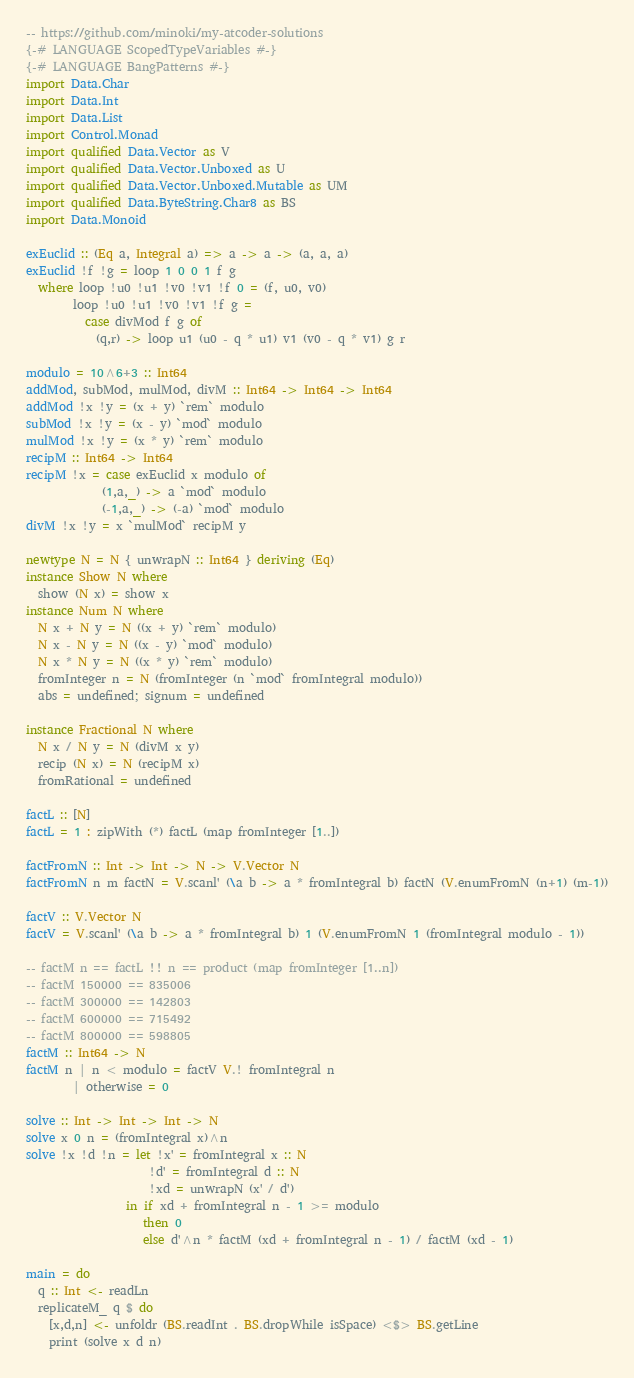<code> <loc_0><loc_0><loc_500><loc_500><_Haskell_>-- https://github.com/minoki/my-atcoder-solutions
{-# LANGUAGE ScopedTypeVariables #-}
{-# LANGUAGE BangPatterns #-}
import Data.Char
import Data.Int
import Data.List
import Control.Monad
import qualified Data.Vector as V
import qualified Data.Vector.Unboxed as U
import qualified Data.Vector.Unboxed.Mutable as UM
import qualified Data.ByteString.Char8 as BS
import Data.Monoid

exEuclid :: (Eq a, Integral a) => a -> a -> (a, a, a)
exEuclid !f !g = loop 1 0 0 1 f g
  where loop !u0 !u1 !v0 !v1 !f 0 = (f, u0, v0)
        loop !u0 !u1 !v0 !v1 !f g =
          case divMod f g of
            (q,r) -> loop u1 (u0 - q * u1) v1 (v0 - q * v1) g r

modulo = 10^6+3 :: Int64
addMod, subMod, mulMod, divM :: Int64 -> Int64 -> Int64
addMod !x !y = (x + y) `rem` modulo
subMod !x !y = (x - y) `mod` modulo
mulMod !x !y = (x * y) `rem` modulo
recipM :: Int64 -> Int64
recipM !x = case exEuclid x modulo of
             (1,a,_) -> a `mod` modulo
             (-1,a,_) -> (-a) `mod` modulo
divM !x !y = x `mulMod` recipM y

newtype N = N { unwrapN :: Int64 } deriving (Eq)
instance Show N where
  show (N x) = show x
instance Num N where
  N x + N y = N ((x + y) `rem` modulo)
  N x - N y = N ((x - y) `mod` modulo)
  N x * N y = N ((x * y) `rem` modulo)
  fromInteger n = N (fromInteger (n `mod` fromIntegral modulo))
  abs = undefined; signum = undefined

instance Fractional N where
  N x / N y = N (divM x y)
  recip (N x) = N (recipM x)
  fromRational = undefined

factL :: [N]
factL = 1 : zipWith (*) factL (map fromInteger [1..])

factFromN :: Int -> Int -> N -> V.Vector N
factFromN n m factN = V.scanl' (\a b -> a * fromIntegral b) factN (V.enumFromN (n+1) (m-1))

factV :: V.Vector N
factV = V.scanl' (\a b -> a * fromIntegral b) 1 (V.enumFromN 1 (fromIntegral modulo - 1))

-- factM n == factL !! n == product (map fromInteger [1..n])
-- factM 150000 == 835006
-- factM 300000 == 142803
-- factM 600000 == 715492
-- factM 800000 == 598805
factM :: Int64 -> N
factM n | n < modulo = factV V.! fromIntegral n
        | otherwise = 0

solve :: Int -> Int -> Int -> N
solve x 0 n = (fromIntegral x)^n
solve !x !d !n = let !x' = fromIntegral x :: N
                     !d' = fromIntegral d :: N
                     !xd = unwrapN (x' / d')
                 in if xd + fromIntegral n - 1 >= modulo
                    then 0
                    else d'^n * factM (xd + fromIntegral n - 1) / factM (xd - 1)

main = do
  q :: Int <- readLn
  replicateM_ q $ do
    [x,d,n] <- unfoldr (BS.readInt . BS.dropWhile isSpace) <$> BS.getLine
    print (solve x d n)
</code> 